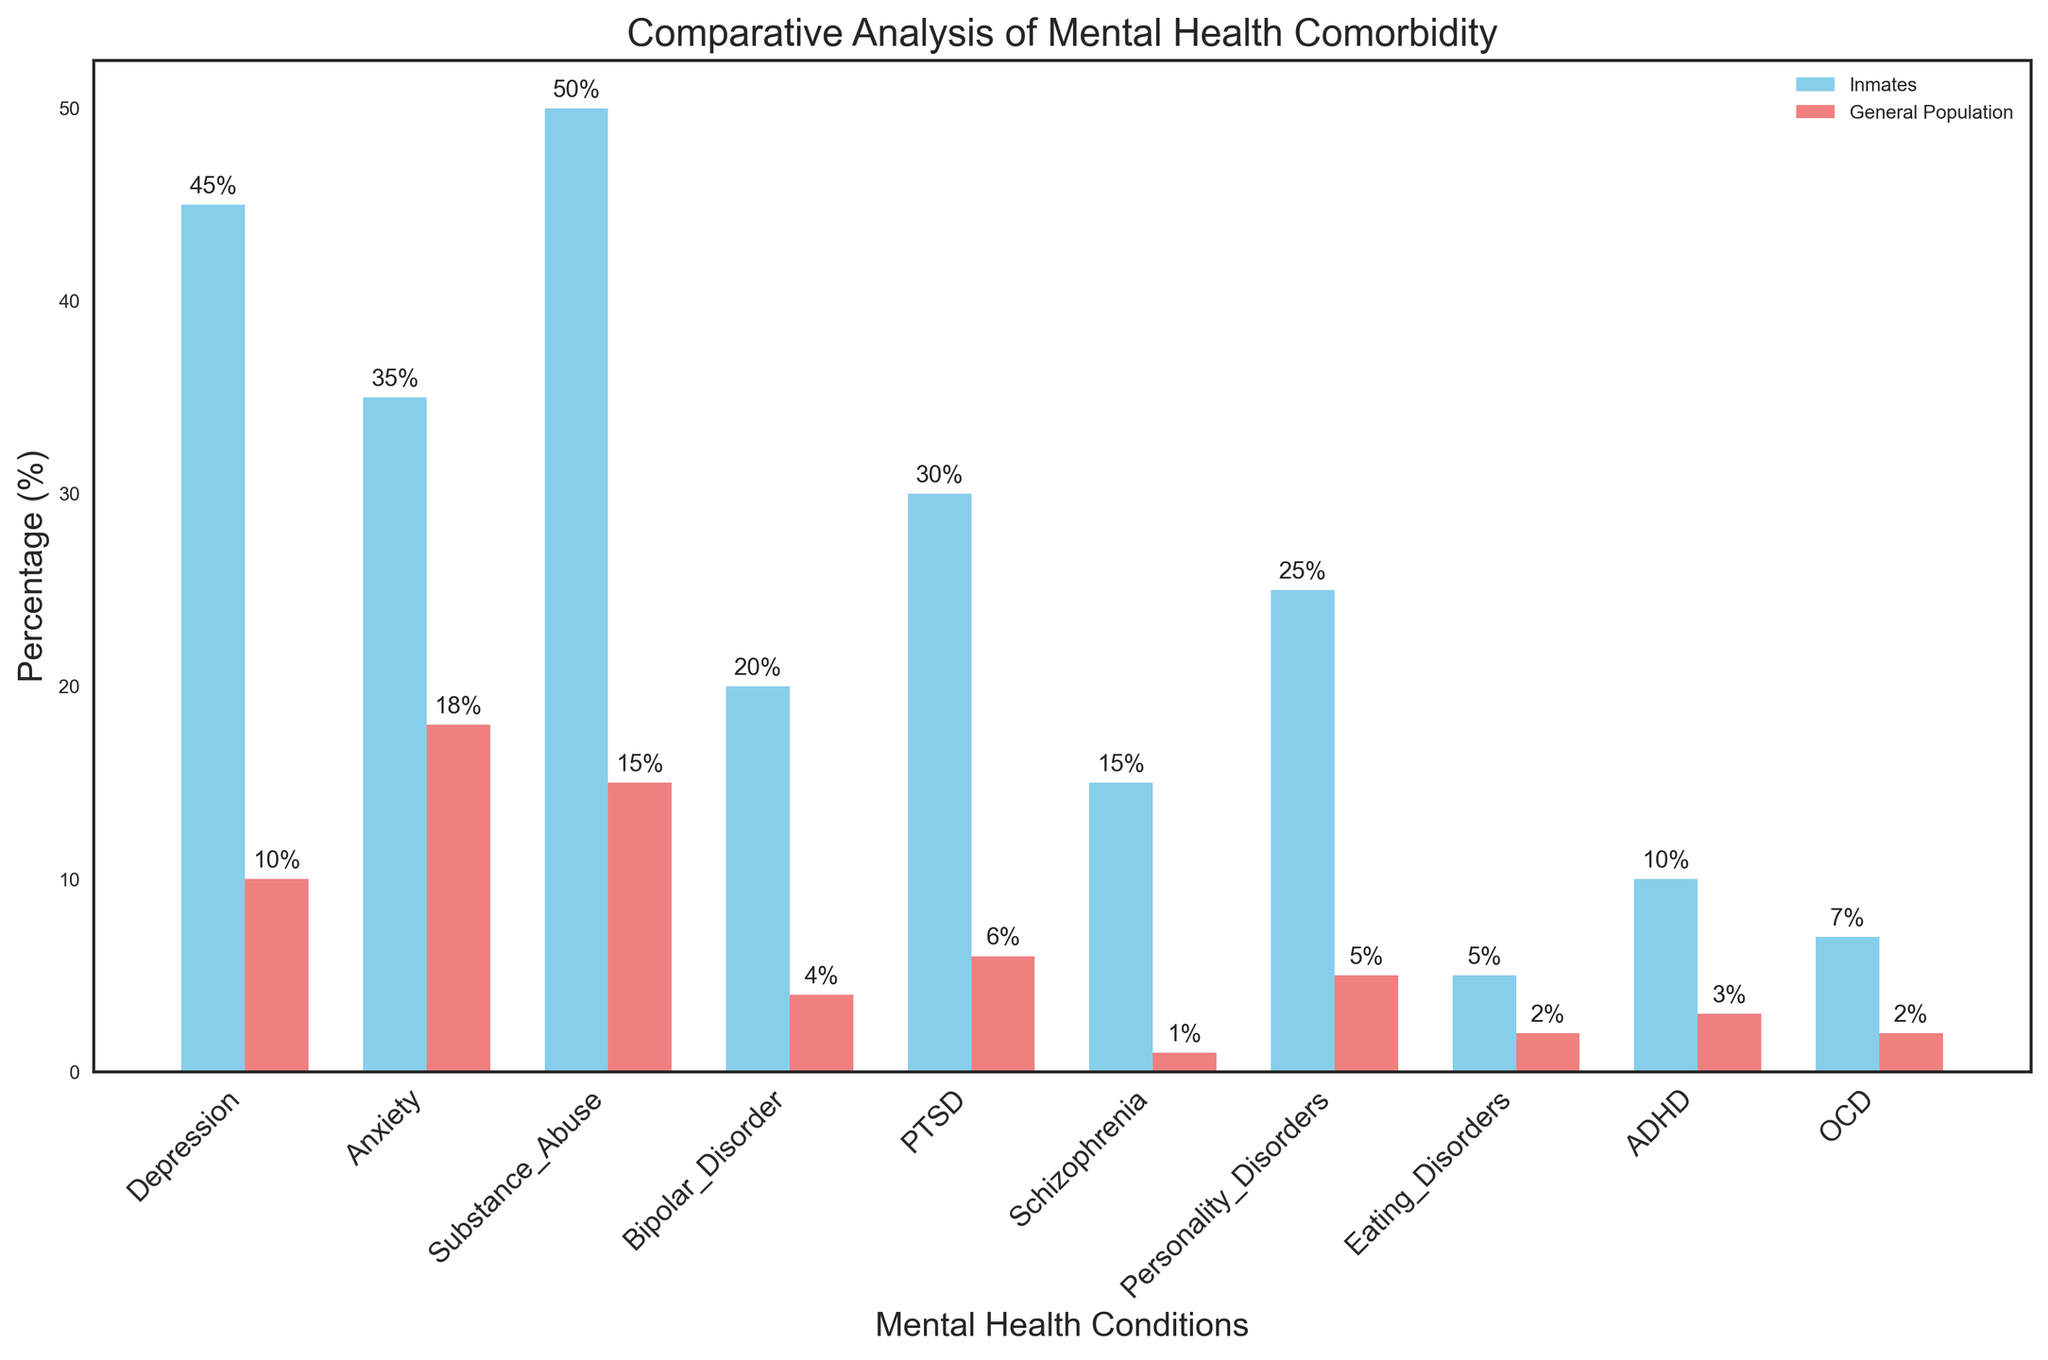Which category has the highest percentage of inmates with mental health conditions? By comparing the heights of the bars in the "Inmates" series, we see that the highest bar corresponds to the "Substance Abuse" category.
Answer: Substance Abuse What is the difference in percentage points between inmates and the general population for depression? For Depression, the percentage among inmates is 45% and for the general population, it is 10%. The difference is 45 - 10.
Answer: 35 Which mental health conditions have the smallest disparity between inmates and the general population? By examining the differences in bar heights for each category, the smallest disparity is found in "Eating Disorders" (5% - 2% = 3%).
Answer: Eating Disorders How many times more prevalent is schizophrenia among inmates compared to the general population? The percentage of inmates with Schizophrenia is 15% and in the general population, it is 1%. The ratio is 15 / 1.
Answer: 15 times What is the average percentage of inmates across all listed mental health conditions? Sum all percentages in the "Inmates" column (45 + 35 + 50 + 20 + 30 + 15 + 25 + 5 + 10 + 7 = 242) and divide by the number of conditions (10).
Answer: 24.2% What is the ratio of inmates to the general population for bipolar disorder in percentage terms? The percentage in inmates for Bipolar Disorder is 20%, and for the general population, it is 4%. The ratio is 20 / 4.
Answer: 5 to 1 Which two mental health conditions show the largest visual difference between inmates and the general population? The largest visual differences can be identified by finding the largest gaps between pairs of bars. These are "Substance Abuse" (50% - 15% = 35%) and "Schizophrenia" (15% - 1% = 14%).
Answer: Substance Abuse and Schizophrenia Considering the bar color used for the inmates group, what are the three conditions with the highest percentages? The bars for "Inmates" are colored sky blue. The three tallest bars for this color correspond to "Substance Abuse" (50%), "Depression" (45%), and "Anxiety" (35%).
Answer: Substance Abuse, Depression, Anxiety If you combine the percentages for PTSD and ADHD among inmates, what would be the total? For inmates, the percentage for PTSD is 30% and for ADHD, it is 10%. The combined total is 30 + 10.
Answer: 40% Are there any conditions where the percentage is higher in the general population than in inmates? By comparing all categories, there are no conditions where the bar for the general population is taller than the corresponding bar for inmates.
Answer: No 